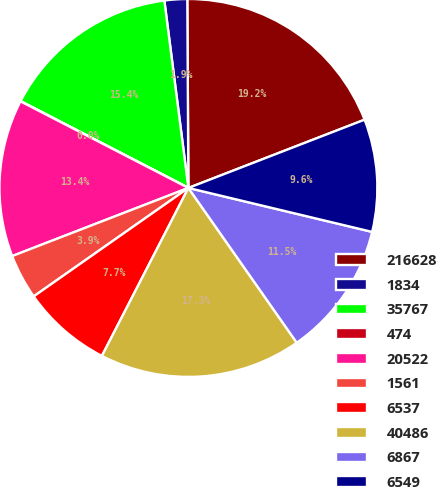Convert chart. <chart><loc_0><loc_0><loc_500><loc_500><pie_chart><fcel>216628<fcel>1834<fcel>35767<fcel>474<fcel>20522<fcel>1561<fcel>6537<fcel>40486<fcel>6867<fcel>6549<nl><fcel>19.21%<fcel>1.94%<fcel>15.37%<fcel>0.02%<fcel>13.45%<fcel>3.86%<fcel>7.7%<fcel>17.29%<fcel>11.54%<fcel>9.62%<nl></chart> 